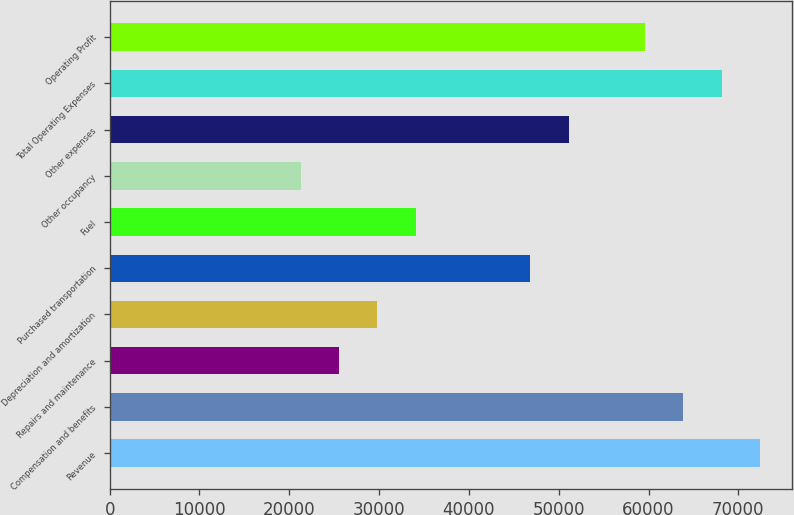<chart> <loc_0><loc_0><loc_500><loc_500><bar_chart><fcel>Revenue<fcel>Compensation and benefits<fcel>Repairs and maintenance<fcel>Depreciation and amortization<fcel>Purchased transportation<fcel>Fuel<fcel>Other occupancy<fcel>Other expenses<fcel>Total Operating Expenses<fcel>Operating Profit<nl><fcel>72385.2<fcel>63869.7<fcel>25550<fcel>29807.7<fcel>46838.7<fcel>34065.5<fcel>21292.2<fcel>51096.5<fcel>68127.5<fcel>59612<nl></chart> 